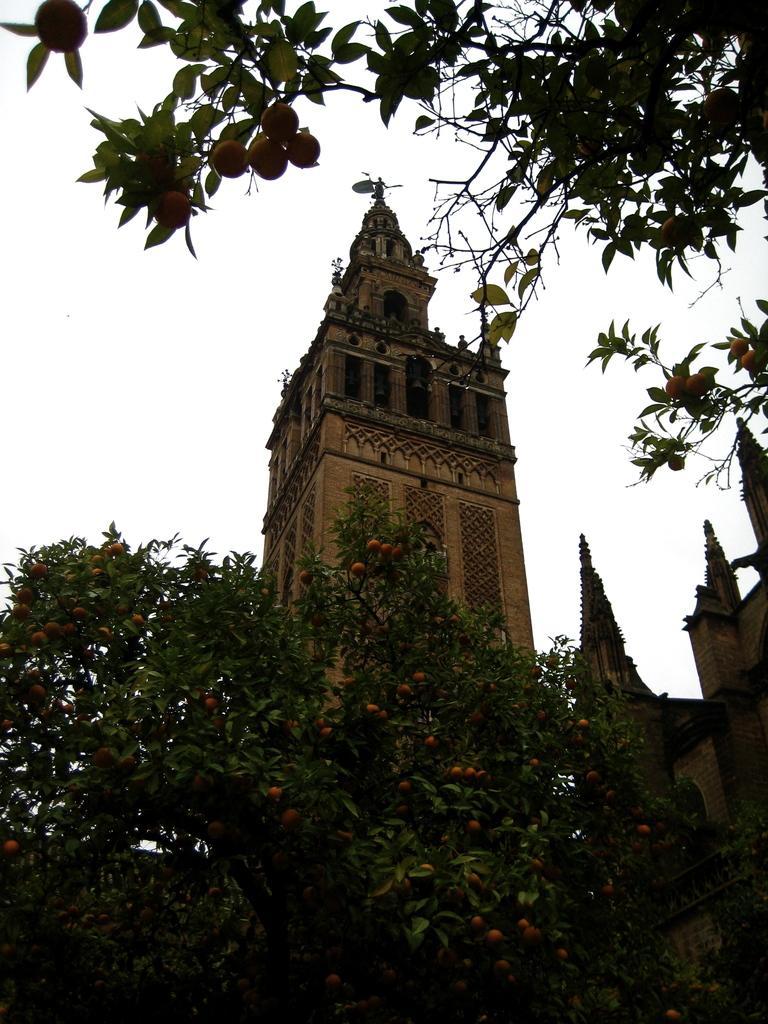How would you summarize this image in a sentence or two? In the image we can see there are fruits on the tree and there is a building. There is a clear sky. 